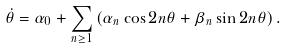Convert formula to latex. <formula><loc_0><loc_0><loc_500><loc_500>\dot { \theta } = \alpha _ { 0 } + \sum _ { n \geq 1 } \left ( \alpha _ { n } \cos 2 n \theta + \beta _ { n } \sin 2 n \theta \right ) .</formula> 